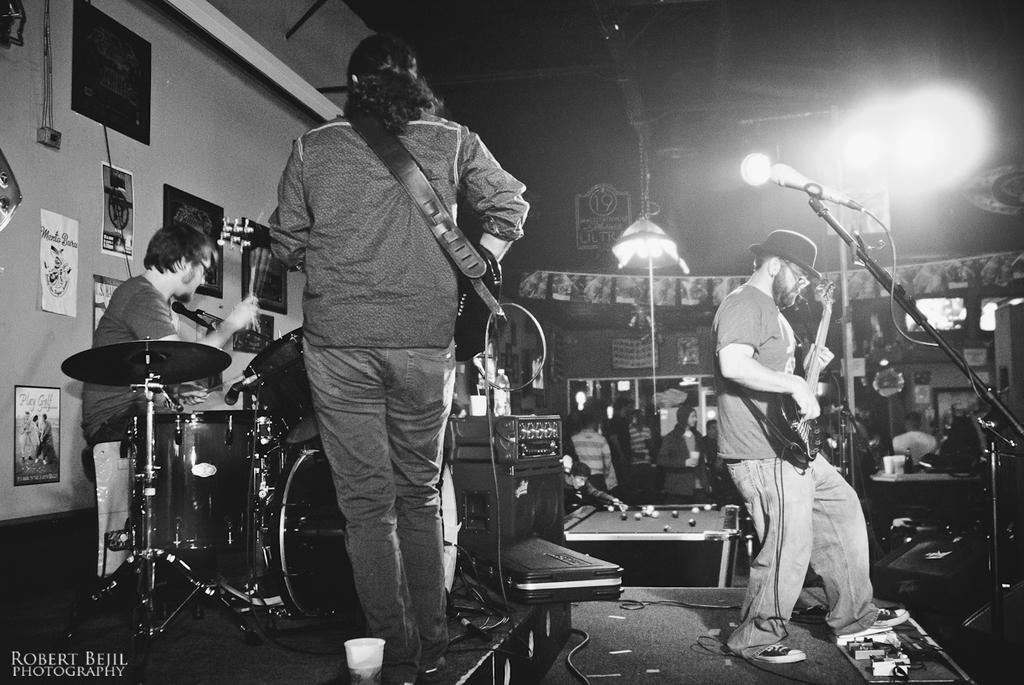What are the people on the stage doing? The people on the stage are playing musical instruments. Can you describe the background of the image? There is a group of people, lights, buildings, and frames visible in the background. How many people are playing musical instruments on the stage? The number of people playing musical instruments on the stage is not specified, but there are people on the stage. What type of pan is being used to cook food in the image? There is no pan or cooking activity present in the image. Can you describe the pocket of the person in the image? There is no person or pocket visible in the image. 